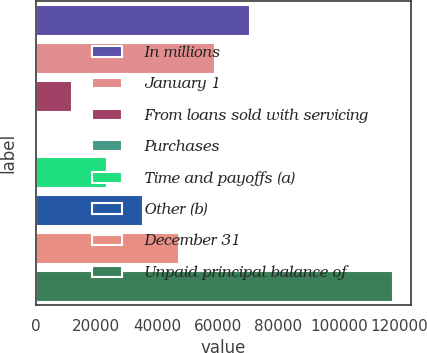Convert chart. <chart><loc_0><loc_0><loc_500><loc_500><bar_chart><fcel>In millions<fcel>January 1<fcel>From loans sold with servicing<fcel>Purchases<fcel>Time and payoffs (a)<fcel>Other (b)<fcel>December 31<fcel>Unpaid principal balance of<nl><fcel>70860.8<fcel>59061.5<fcel>11864.3<fcel>65<fcel>23663.6<fcel>35462.9<fcel>47262.2<fcel>118058<nl></chart> 